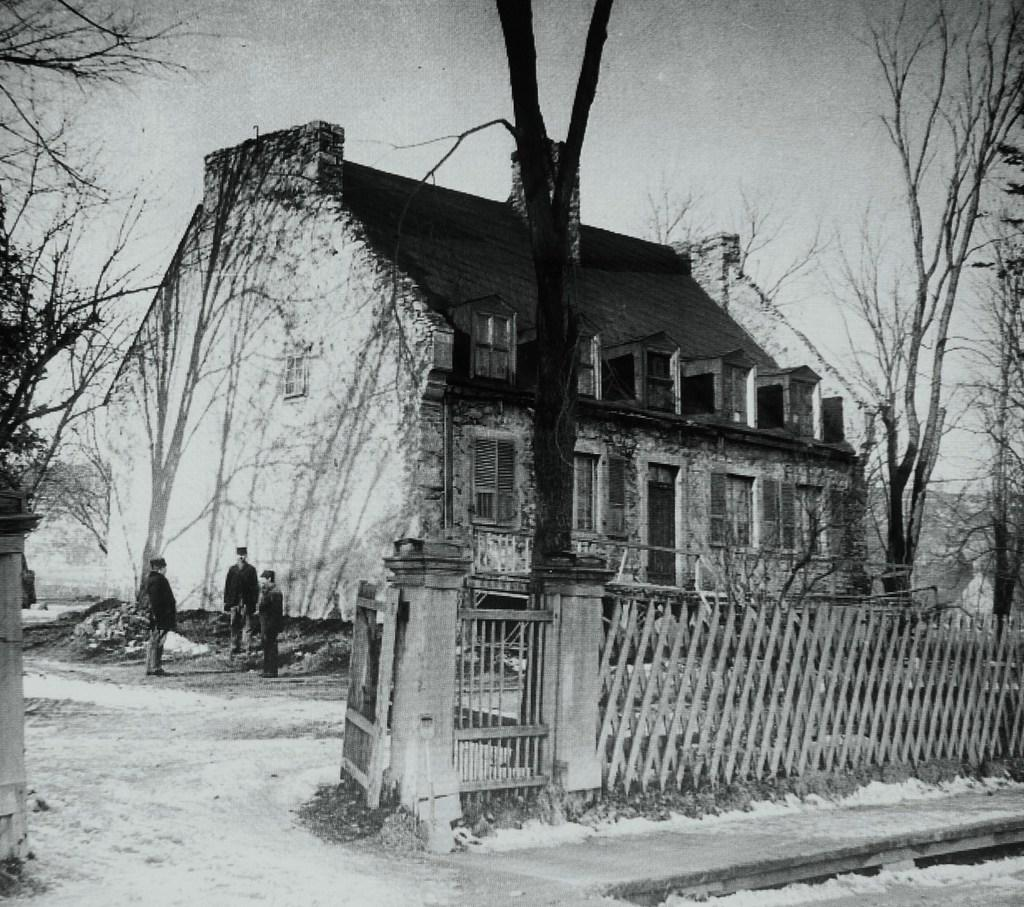What is the color scheme of the image? The image is black and white. What is the main subject in the image? There is a house in the middle of the image. What features can be seen on the house? The house has windows and doors. Where is the gate located in the image? The gate is on the left side of the image. What else is present in the middle of the image besides the house? There are trees in the middle of the image. What is visible at the top of the image? The sky is visible at the top of the image. What type of pain is being expressed by the trees in the image? There is no indication of pain in the image, as it features a house, trees, and a gate. What rhythm is being played by the jar in the image? There is no jar present in the image, and therefore no rhythm can be associated with it. 